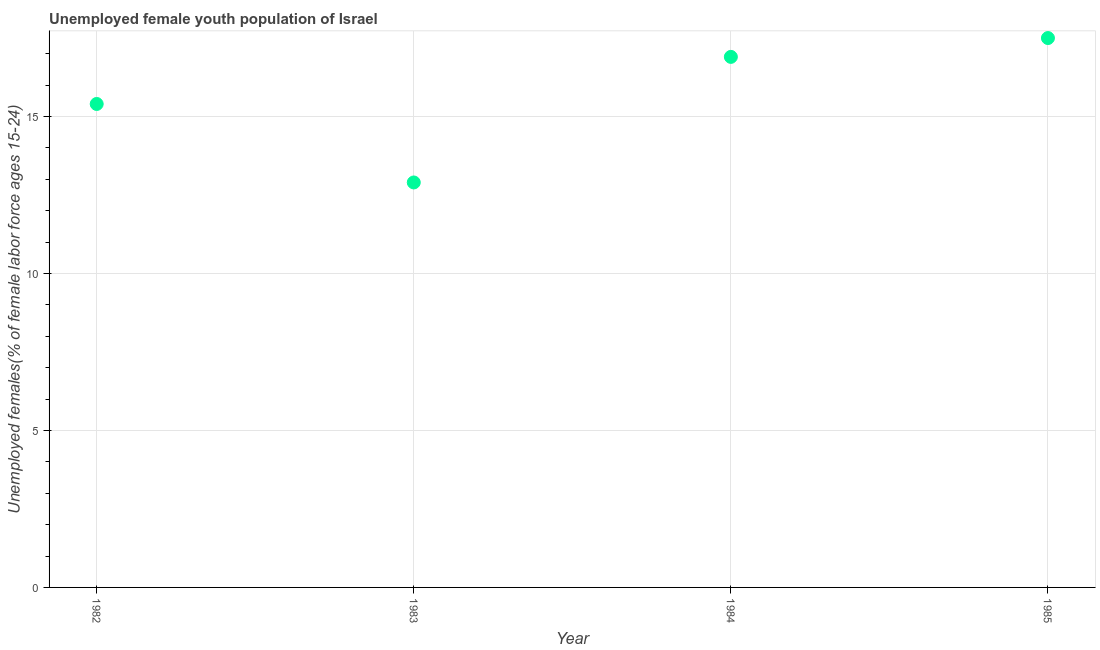What is the unemployed female youth in 1982?
Your answer should be very brief. 15.4. Across all years, what is the minimum unemployed female youth?
Make the answer very short. 12.9. What is the sum of the unemployed female youth?
Your response must be concise. 62.7. What is the average unemployed female youth per year?
Your answer should be compact. 15.67. What is the median unemployed female youth?
Offer a terse response. 16.15. What is the ratio of the unemployed female youth in 1983 to that in 1985?
Provide a short and direct response. 0.74. Is the difference between the unemployed female youth in 1984 and 1985 greater than the difference between any two years?
Give a very brief answer. No. What is the difference between the highest and the second highest unemployed female youth?
Provide a short and direct response. 0.6. Is the sum of the unemployed female youth in 1983 and 1985 greater than the maximum unemployed female youth across all years?
Ensure brevity in your answer.  Yes. What is the difference between the highest and the lowest unemployed female youth?
Keep it short and to the point. 4.6. In how many years, is the unemployed female youth greater than the average unemployed female youth taken over all years?
Your response must be concise. 2. Does the unemployed female youth monotonically increase over the years?
Make the answer very short. No. How many dotlines are there?
Your answer should be very brief. 1. How many years are there in the graph?
Offer a terse response. 4. What is the difference between two consecutive major ticks on the Y-axis?
Make the answer very short. 5. Are the values on the major ticks of Y-axis written in scientific E-notation?
Give a very brief answer. No. Does the graph contain any zero values?
Offer a terse response. No. Does the graph contain grids?
Your answer should be compact. Yes. What is the title of the graph?
Offer a terse response. Unemployed female youth population of Israel. What is the label or title of the Y-axis?
Keep it short and to the point. Unemployed females(% of female labor force ages 15-24). What is the Unemployed females(% of female labor force ages 15-24) in 1982?
Provide a succinct answer. 15.4. What is the Unemployed females(% of female labor force ages 15-24) in 1983?
Your answer should be compact. 12.9. What is the Unemployed females(% of female labor force ages 15-24) in 1984?
Ensure brevity in your answer.  16.9. What is the Unemployed females(% of female labor force ages 15-24) in 1985?
Provide a short and direct response. 17.5. What is the difference between the Unemployed females(% of female labor force ages 15-24) in 1982 and 1983?
Keep it short and to the point. 2.5. What is the difference between the Unemployed females(% of female labor force ages 15-24) in 1983 and 1985?
Make the answer very short. -4.6. What is the ratio of the Unemployed females(% of female labor force ages 15-24) in 1982 to that in 1983?
Your response must be concise. 1.19. What is the ratio of the Unemployed females(% of female labor force ages 15-24) in 1982 to that in 1984?
Make the answer very short. 0.91. What is the ratio of the Unemployed females(% of female labor force ages 15-24) in 1983 to that in 1984?
Offer a terse response. 0.76. What is the ratio of the Unemployed females(% of female labor force ages 15-24) in 1983 to that in 1985?
Offer a very short reply. 0.74. What is the ratio of the Unemployed females(% of female labor force ages 15-24) in 1984 to that in 1985?
Give a very brief answer. 0.97. 